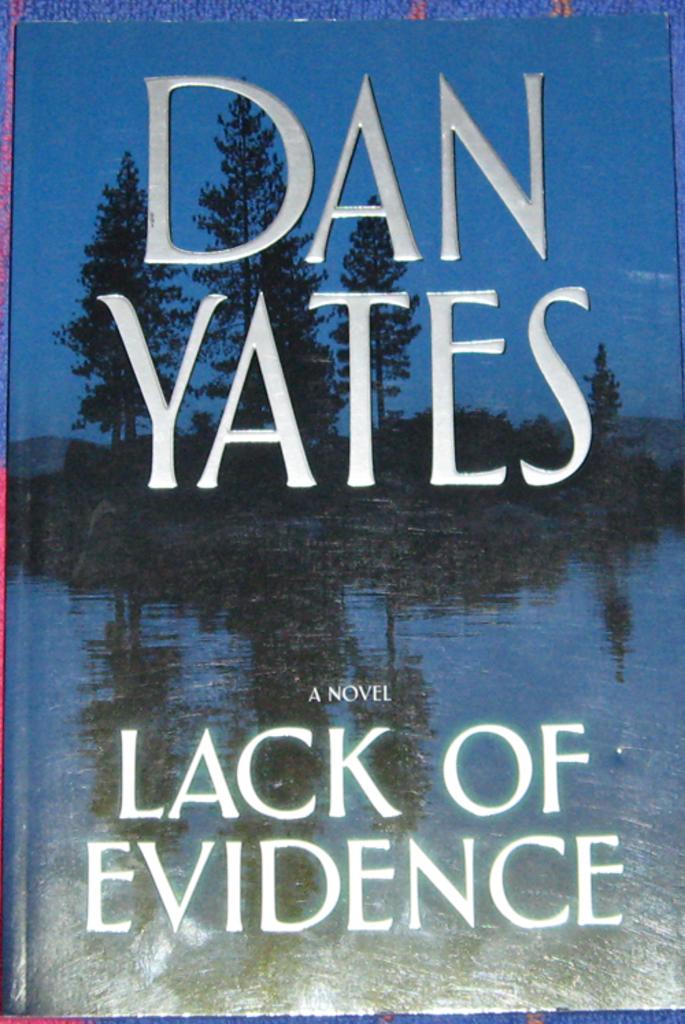Who is the author of this novel?
Your response must be concise. Dan yates. 